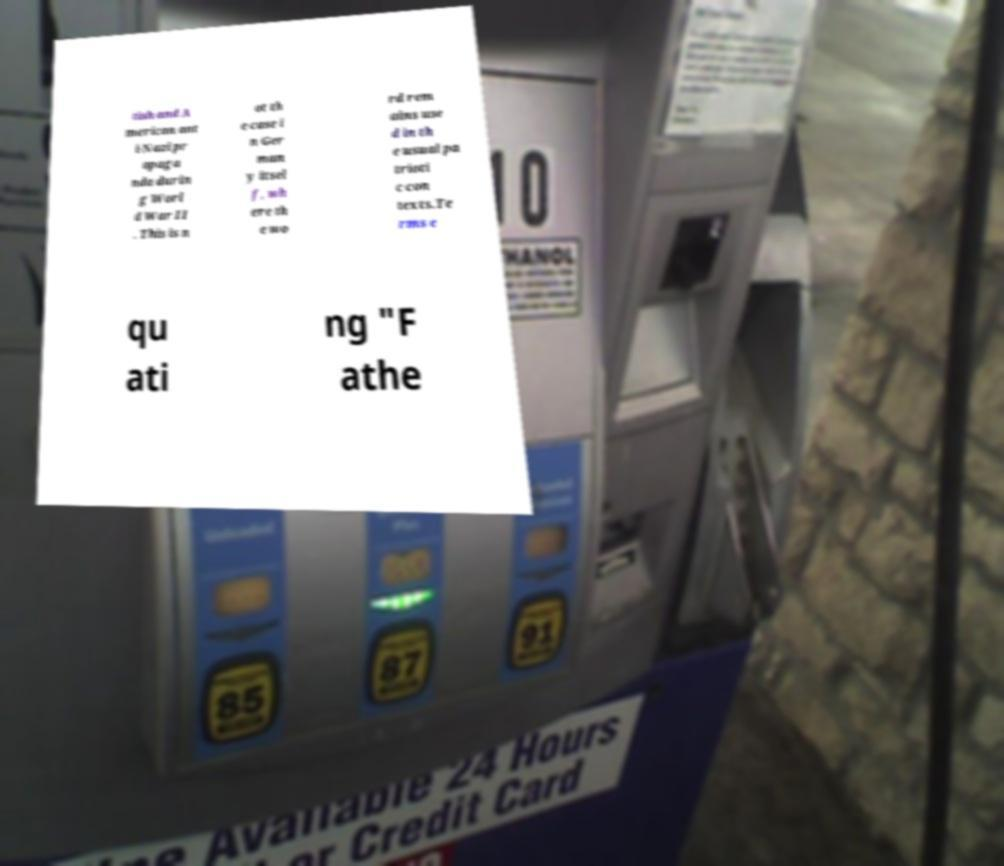Can you read and provide the text displayed in the image?This photo seems to have some interesting text. Can you extract and type it out for me? tish and A merican ant i-Nazi pr opaga nda durin g Worl d War II . This is n ot th e case i n Ger man y itsel f, wh ere th e wo rd rem ains use d in th e usual pa trioti c con texts.Te rms e qu ati ng "F athe 